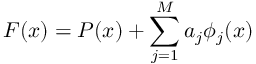Convert formula to latex. <formula><loc_0><loc_0><loc_500><loc_500>F ( x ) = P ( x ) + \sum _ { j = 1 } ^ { M } a _ { j } \phi _ { j } ( x )</formula> 